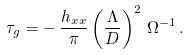<formula> <loc_0><loc_0><loc_500><loc_500>\tau _ { g } = - \, \frac { h _ { x x } } { \pi } \left ( \frac { \Lambda } { D } \right ) ^ { 2 } \, \Omega ^ { - 1 } \, .</formula> 